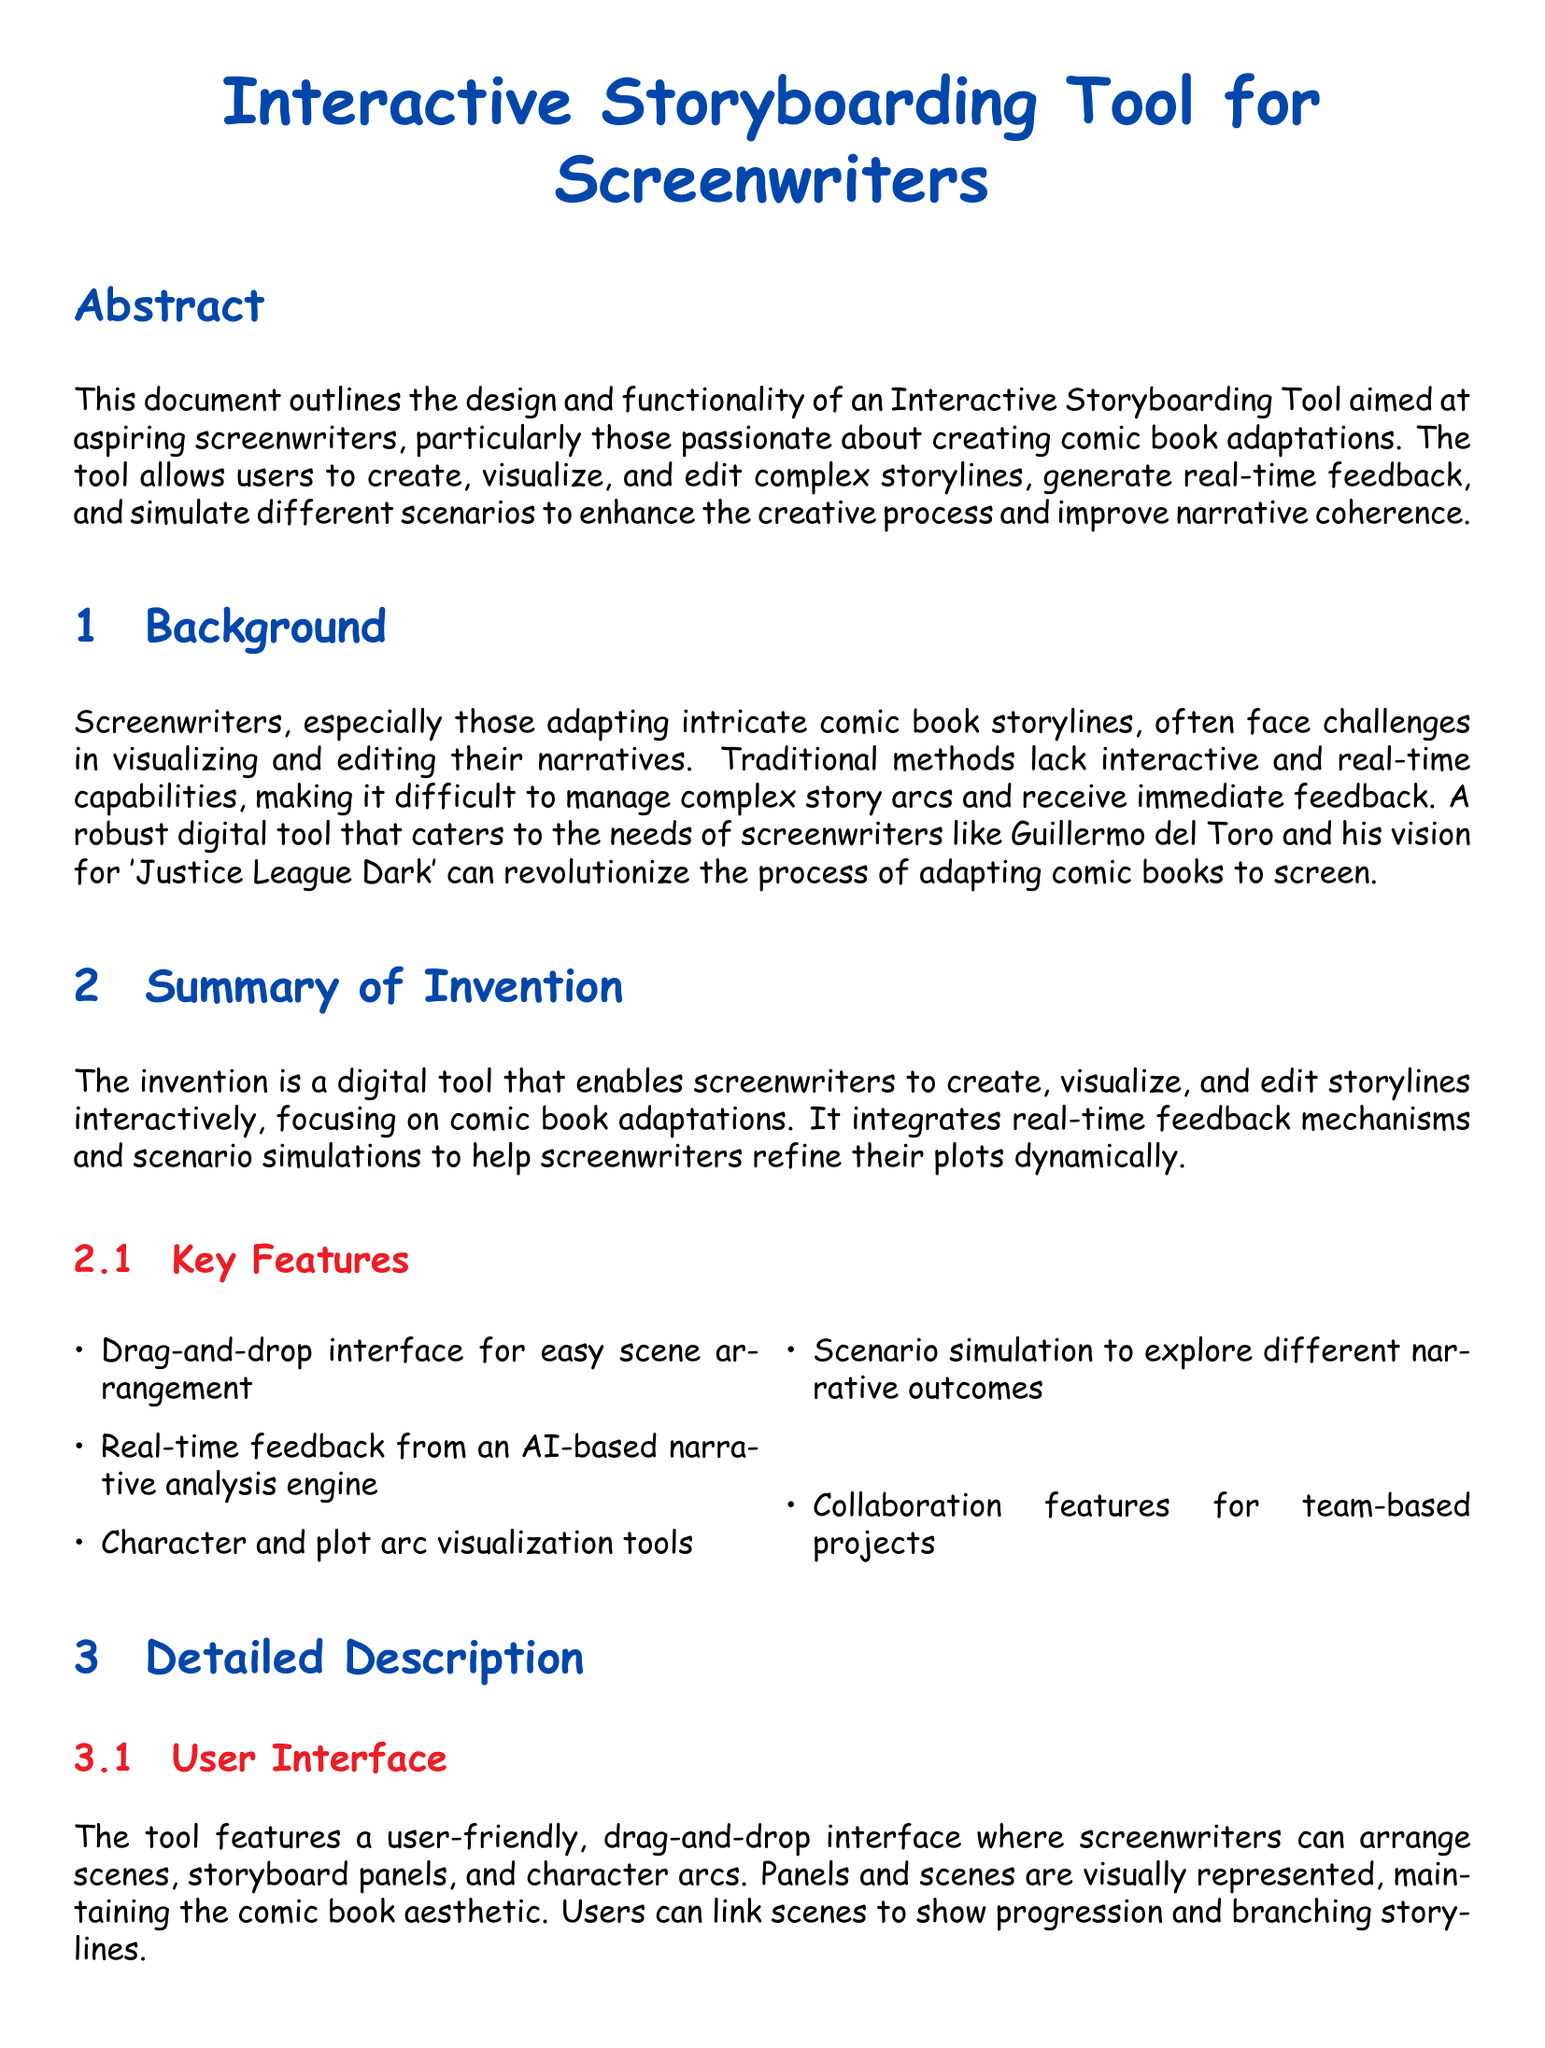What is the purpose of the Interactive Storyboarding Tool? The tool aims to enable screenwriters to create, visualize, and edit storylines, particularly for comic book adaptations.
Answer: Create, visualize, and edit storylines What feature allows users to test various story pathways? The document describes a feature that enables scenario testing for exploring different narrative outcomes.
Answer: Scenario simulation Who is the target audience mentioned for this tool? The primary users identified in the document are aspiring screenwriters, especially those focused on comic book adaptations.
Answer: Aspiring screenwriters What type of user interface does the tool feature? The user interface is characterized as drag-and-drop, making scene arrangement intuitive and easy.
Answer: Drag-and-drop interface What does the AI engine provide during the writing process? The AI engine analyzes narrative structure and provides feedback, helping identify plot holes and inconsistencies.
Answer: Real-time feedback What kind of collaboration features does the tool include? Collaboration features involve real-time multi-user editing and discussions tied to scenes or characters.
Answer: Team-based collaboration In which section is the summary of the invention located? The summary of the invention is located in the section labeled "Summary of Invention."
Answer: Summary of Invention What color represents the section titles in the document? Section titles are represented in a specific color defined as comic blue in the document.
Answer: Comic blue 